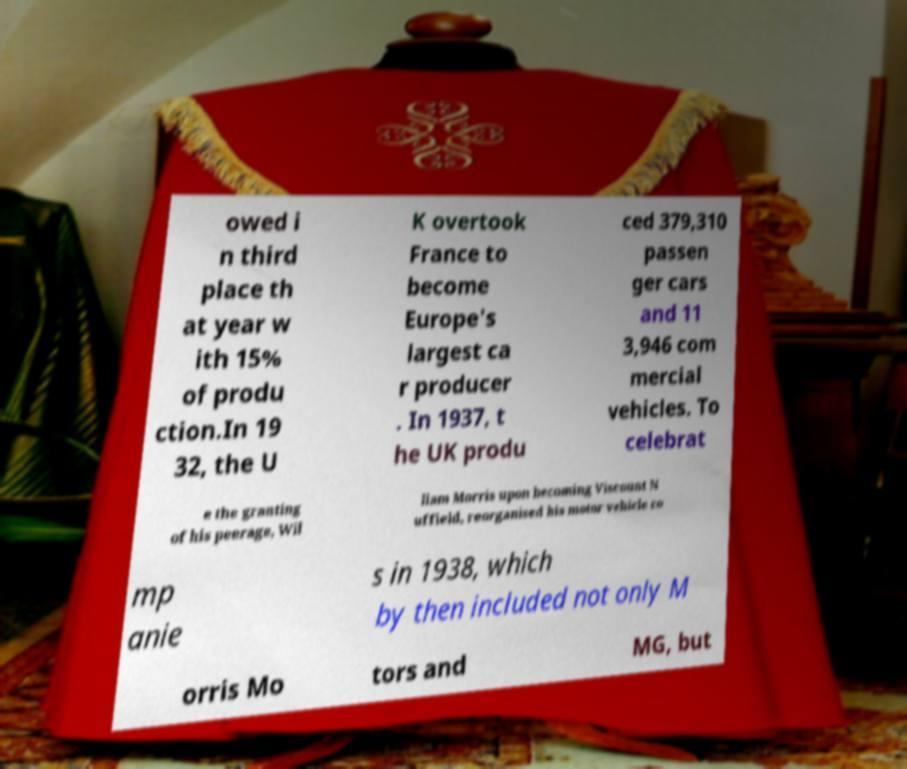I need the written content from this picture converted into text. Can you do that? owed i n third place th at year w ith 15% of produ ction.In 19 32, the U K overtook France to become Europe's largest ca r producer . In 1937, t he UK produ ced 379,310 passen ger cars and 11 3,946 com mercial vehicles. To celebrat e the granting of his peerage, Wil liam Morris upon becoming Viscount N uffield, reorganised his motor vehicle co mp anie s in 1938, which by then included not only M orris Mo tors and MG, but 